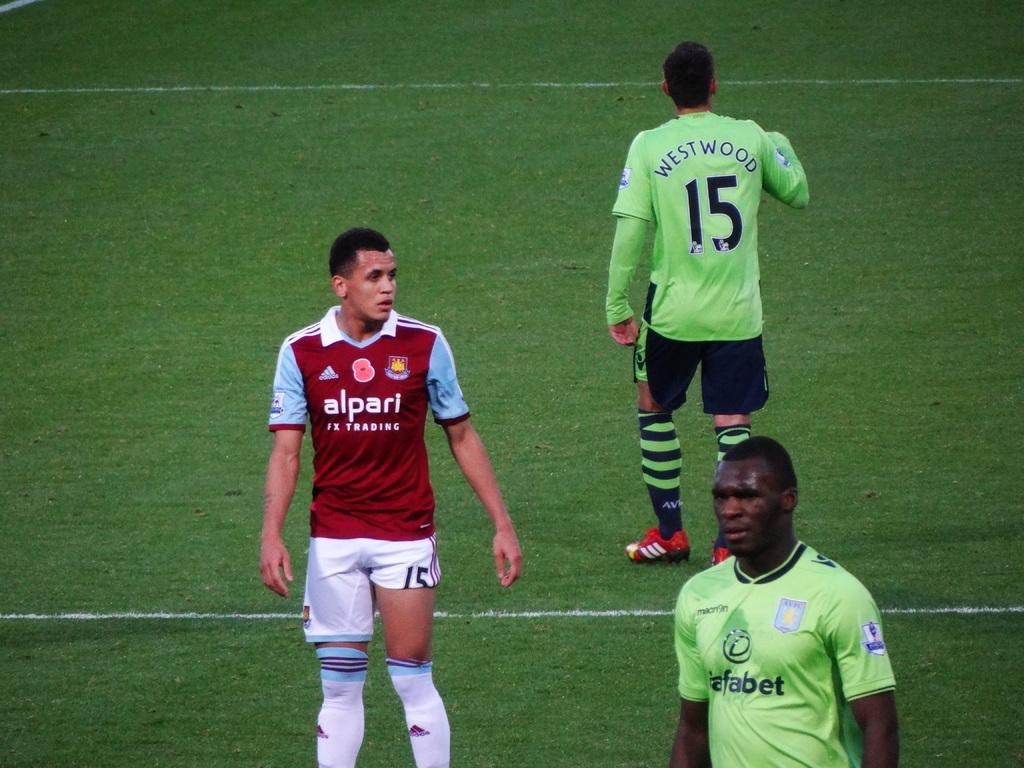What is number 15's name?
Provide a short and direct response. Westwood. What is the name of the team of the man in the red shirt?
Make the answer very short. Alpari. 